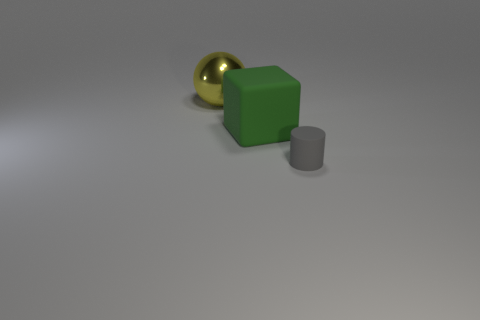Add 3 cylinders. How many objects exist? 6 Subtract 1 cylinders. How many cylinders are left? 0 Subtract 0 blue cylinders. How many objects are left? 3 Subtract all cubes. How many objects are left? 2 Subtract all purple cubes. Subtract all yellow cylinders. How many cubes are left? 1 Subtract all cylinders. Subtract all small gray cylinders. How many objects are left? 1 Add 3 big blocks. How many big blocks are left? 4 Add 3 small brown matte things. How many small brown matte things exist? 3 